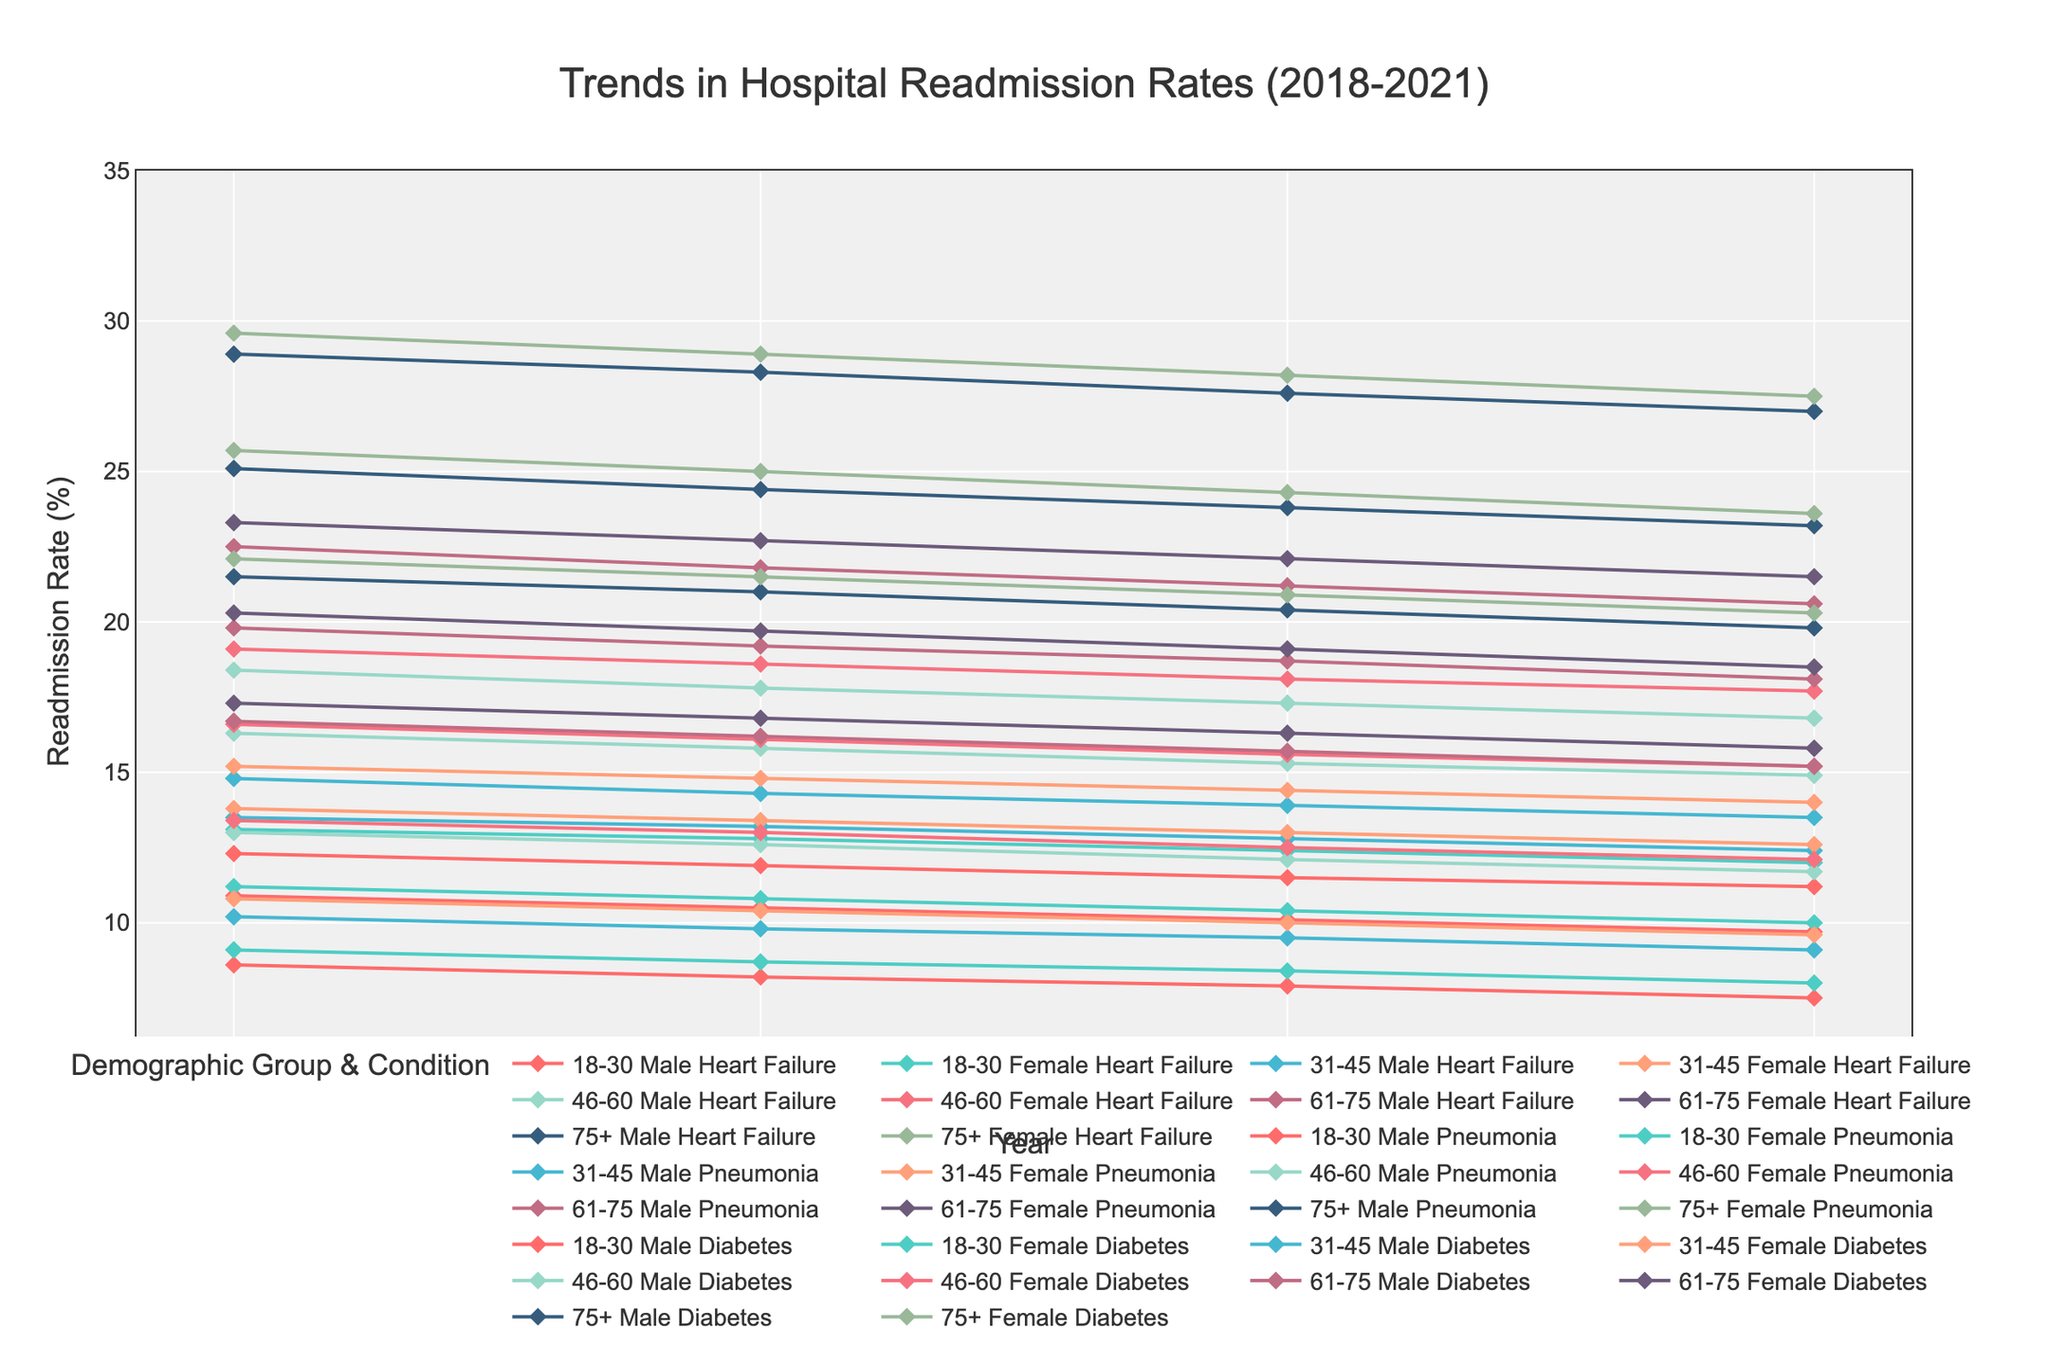What is the title of the figure? The title of the figure is displayed at the top center of the plot.
Answer: Trends in Hospital Readmission Rates (2018-2021) What are the x-axis and y-axis labels in the figure? The x-axis label, located at the bottom of the plot, indicates the year, and the y-axis label, located on the left side, indicates the readmission rate as a percentage.
Answer: Year and Readmission Rate (%) Which age group has the highest readmission rate for heart failure in 2021? By examining the lines representing different age groups for heart failure in 2021, the '75+' group has the highest point on the y-axis.
Answer: 75+ How does the readmission rate for pneumonia in females aged 46-60 change from 2018 to 2021? By locating the line representing pneumonia in females aged 46-60, you can see the rate decreases from 16.6% in 2018 to 15.2% in 2021.
Answer: It decreases Compare the readmission rates for diabetes in males aged 18-30 and females aged 75+ in 2019. Which group has a higher rate? By locating the specific lines on the plot and comparing their y-values for 2019, females aged 75+ have a higher rate (21.5%) than males aged 18-30 (8.2%).
Answer: Females aged 75+ What is the overall trend in readmission rates for heart failure in males across all age groups from 2018 to 2021? By examining the lines for heart failure in males across all age groups, a consistent downward trend is observed in readmission rates from 2018 to 2021.
Answer: Downward trend Which demographic group showed the steepest decline in readmission rates for diabetes between 2018 and 2021? By comparing the slopes of the lines representing diabetes readmission rates, males aged 18-30 exhibited the steepest decline from 8.6% in 2018 to 7.5% in 2021.
Answer: Males aged 18-30 What is the average readmission rate for heart failure in females aged 61-75 over the four years? The average is calculated by summing the readmission rates for 2018 to 2021 (23.3 + 22.7 + 22.1 + 21.5) and dividing by 4. (23.3 + 22.7 + 22.1 + 21.5) / 4 = 22.4
Answer: 22.4% Between males aged 75+ with pneumonia and females aged 75+ with heart failure, who had a higher readmission rate in 2020? By comparing the points for 2020, females aged 75+ with heart failure had a rate of 28.2%, while males aged 75+ with pneumonia had a rate of 23.8%.
Answer: Females aged 75+ with heart failure Which condition showed the smallest change in readmission rates across all demographic groups from 2018 to 2021? By examining the lines and their changes in elevation, diabetes shows the smallest overall change in readmission rates across all demographic groups.
Answer: Diabetes 